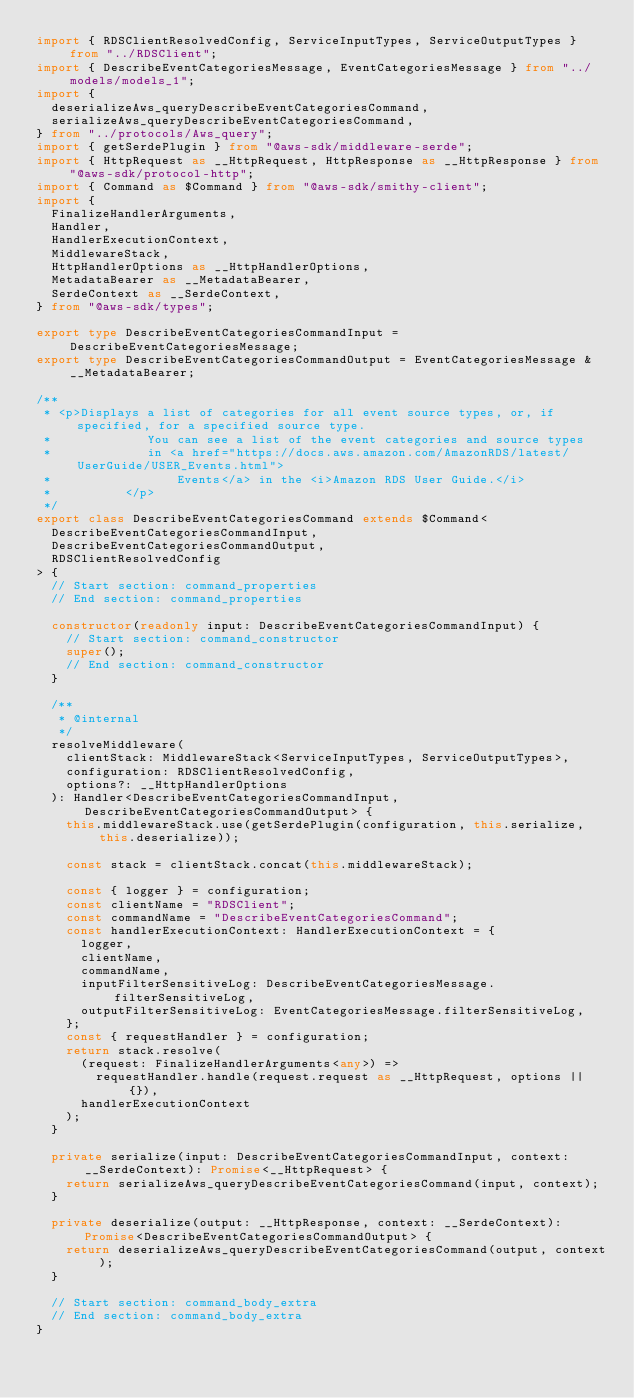<code> <loc_0><loc_0><loc_500><loc_500><_TypeScript_>import { RDSClientResolvedConfig, ServiceInputTypes, ServiceOutputTypes } from "../RDSClient";
import { DescribeEventCategoriesMessage, EventCategoriesMessage } from "../models/models_1";
import {
  deserializeAws_queryDescribeEventCategoriesCommand,
  serializeAws_queryDescribeEventCategoriesCommand,
} from "../protocols/Aws_query";
import { getSerdePlugin } from "@aws-sdk/middleware-serde";
import { HttpRequest as __HttpRequest, HttpResponse as __HttpResponse } from "@aws-sdk/protocol-http";
import { Command as $Command } from "@aws-sdk/smithy-client";
import {
  FinalizeHandlerArguments,
  Handler,
  HandlerExecutionContext,
  MiddlewareStack,
  HttpHandlerOptions as __HttpHandlerOptions,
  MetadataBearer as __MetadataBearer,
  SerdeContext as __SerdeContext,
} from "@aws-sdk/types";

export type DescribeEventCategoriesCommandInput = DescribeEventCategoriesMessage;
export type DescribeEventCategoriesCommandOutput = EventCategoriesMessage & __MetadataBearer;

/**
 * <p>Displays a list of categories for all event source types, or, if specified, for a specified source type.
 *             You can see a list of the event categories and source types
 *             in <a href="https://docs.aws.amazon.com/AmazonRDS/latest/UserGuide/USER_Events.html">
 *                 Events</a> in the <i>Amazon RDS User Guide.</i>
 *          </p>
 */
export class DescribeEventCategoriesCommand extends $Command<
  DescribeEventCategoriesCommandInput,
  DescribeEventCategoriesCommandOutput,
  RDSClientResolvedConfig
> {
  // Start section: command_properties
  // End section: command_properties

  constructor(readonly input: DescribeEventCategoriesCommandInput) {
    // Start section: command_constructor
    super();
    // End section: command_constructor
  }

  /**
   * @internal
   */
  resolveMiddleware(
    clientStack: MiddlewareStack<ServiceInputTypes, ServiceOutputTypes>,
    configuration: RDSClientResolvedConfig,
    options?: __HttpHandlerOptions
  ): Handler<DescribeEventCategoriesCommandInput, DescribeEventCategoriesCommandOutput> {
    this.middlewareStack.use(getSerdePlugin(configuration, this.serialize, this.deserialize));

    const stack = clientStack.concat(this.middlewareStack);

    const { logger } = configuration;
    const clientName = "RDSClient";
    const commandName = "DescribeEventCategoriesCommand";
    const handlerExecutionContext: HandlerExecutionContext = {
      logger,
      clientName,
      commandName,
      inputFilterSensitiveLog: DescribeEventCategoriesMessage.filterSensitiveLog,
      outputFilterSensitiveLog: EventCategoriesMessage.filterSensitiveLog,
    };
    const { requestHandler } = configuration;
    return stack.resolve(
      (request: FinalizeHandlerArguments<any>) =>
        requestHandler.handle(request.request as __HttpRequest, options || {}),
      handlerExecutionContext
    );
  }

  private serialize(input: DescribeEventCategoriesCommandInput, context: __SerdeContext): Promise<__HttpRequest> {
    return serializeAws_queryDescribeEventCategoriesCommand(input, context);
  }

  private deserialize(output: __HttpResponse, context: __SerdeContext): Promise<DescribeEventCategoriesCommandOutput> {
    return deserializeAws_queryDescribeEventCategoriesCommand(output, context);
  }

  // Start section: command_body_extra
  // End section: command_body_extra
}
</code> 